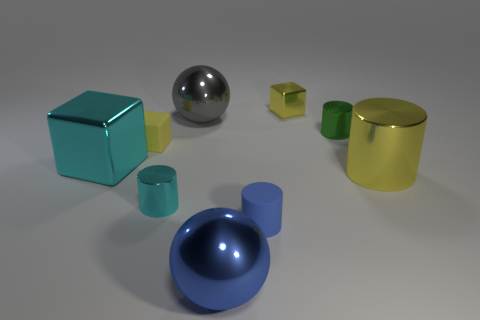Add 1 tiny yellow matte objects. How many objects exist? 10 Subtract all cylinders. How many objects are left? 5 Add 1 metal cubes. How many metal cubes are left? 3 Add 4 large cyan things. How many large cyan things exist? 5 Subtract 0 green spheres. How many objects are left? 9 Subtract all tiny red balls. Subtract all cyan shiny objects. How many objects are left? 7 